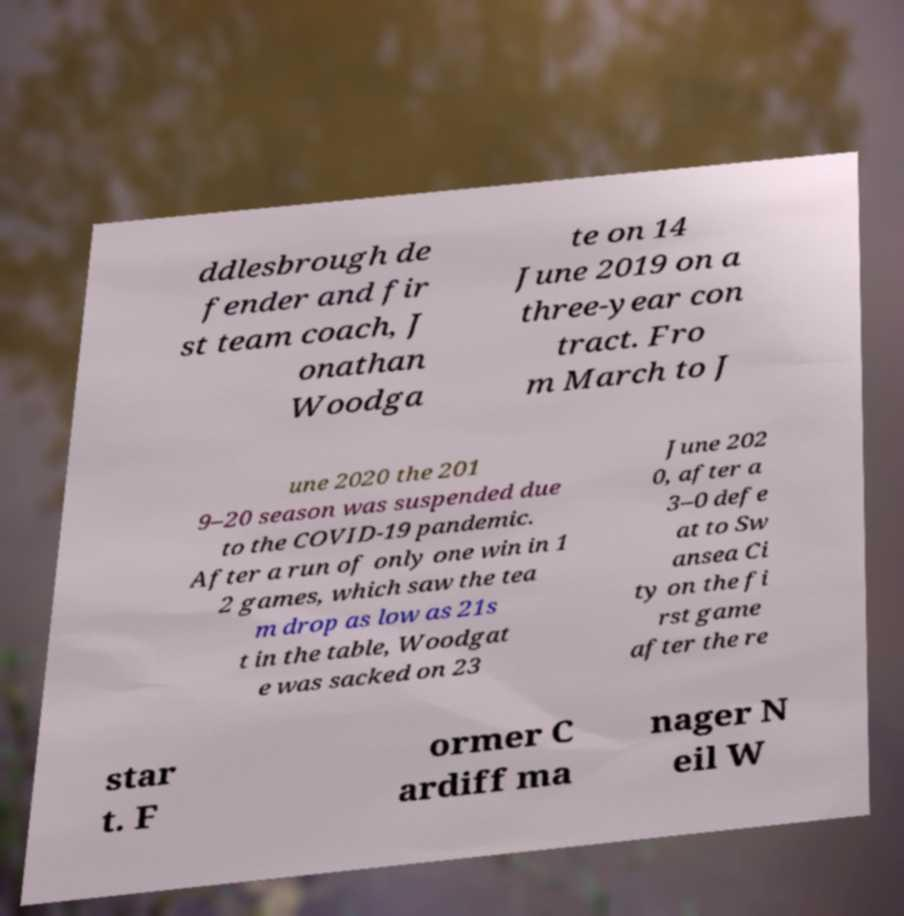For documentation purposes, I need the text within this image transcribed. Could you provide that? ddlesbrough de fender and fir st team coach, J onathan Woodga te on 14 June 2019 on a three-year con tract. Fro m March to J une 2020 the 201 9–20 season was suspended due to the COVID-19 pandemic. After a run of only one win in 1 2 games, which saw the tea m drop as low as 21s t in the table, Woodgat e was sacked on 23 June 202 0, after a 3–0 defe at to Sw ansea Ci ty on the fi rst game after the re star t. F ormer C ardiff ma nager N eil W 